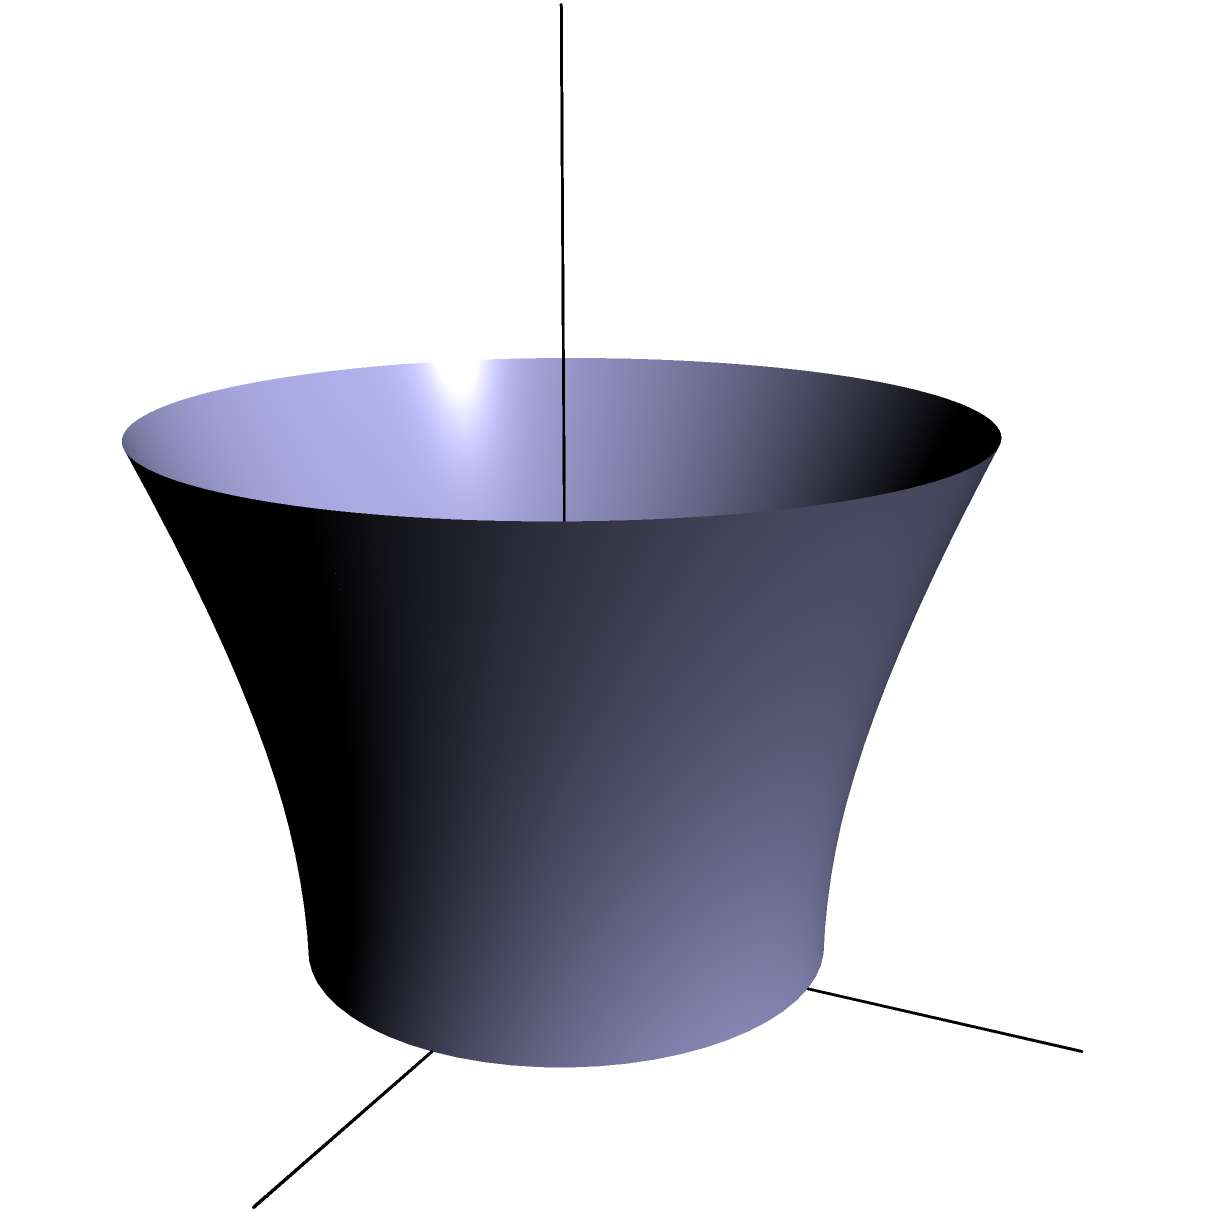You need to calculate the volume of a new hyperbolic water tank for your farm's irrigation system. The tank's shape is modeled by the hyperboloid of one sheet, described by the equation $\frac{x^2}{a^2} + \frac{y^2}{b^2} - \frac{z^2}{c^2} = 1$, where $a=b=2$ and $c=2$. What is the volume of water the tank can hold if it's filled to a height of $h=3$ units? To solve this problem, we'll follow these steps:

1) The volume of a hyperboloid of one sheet from $z=0$ to $z=h$ is given by the formula:

   $$V = \pi ab \left(\frac{h}{c} + \frac{c}{3}\left(\frac{h}{c}\right)^3\right)$$

2) We're given that $a=b=2$ and $c=2$. Let's substitute these values:

   $$V = \pi (2)(2) \left(\frac{h}{2} + \frac{2}{3}\left(\frac{h}{2}\right)^3\right)$$

3) Simplify:

   $$V = 4\pi \left(\frac{h}{2} + \frac{1}{6}\left(\frac{h}{2}\right)^3\right)$$

4) Now, substitute $h=3$:

   $$V = 4\pi \left(\frac{3}{2} + \frac{1}{6}\left(\frac{3}{2}\right)^3\right)$$

5) Calculate:

   $$V = 4\pi \left(\frac{3}{2} + \frac{1}{6}\left(\frac{27}{8}\right)\right)$$
   $$V = 4\pi \left(\frac{3}{2} + \frac{27}{48}\right)$$
   $$V = 4\pi \left(\frac{36}{24} + \frac{27}{48}\right)$$
   $$V = 4\pi \left(\frac{72}{48} + \frac{27}{48}\right)$$
   $$V = 4\pi \left(\frac{99}{48}\right)$$
   $$V = \frac{33\pi}{4} \approx 25.92$$

Therefore, the volume of water the tank can hold is $\frac{33\pi}{4}$ cubic units.
Answer: $\frac{33\pi}{4}$ cubic units 